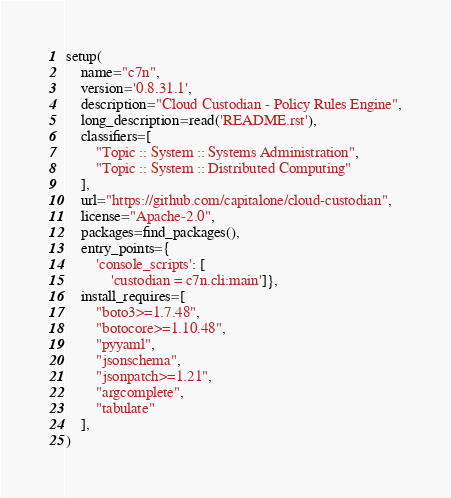Convert code to text. <code><loc_0><loc_0><loc_500><loc_500><_Python_>setup(
    name="c7n",
    version='0.8.31.1',
    description="Cloud Custodian - Policy Rules Engine",
    long_description=read('README.rst'),
    classifiers=[
        "Topic :: System :: Systems Administration",
        "Topic :: System :: Distributed Computing"
    ],
    url="https://github.com/capitalone/cloud-custodian",
    license="Apache-2.0",
    packages=find_packages(),
    entry_points={
        'console_scripts': [
            'custodian = c7n.cli:main']},
    install_requires=[
        "boto3>=1.7.48",
        "botocore>=1.10.48",
        "pyyaml",
        "jsonschema",
        "jsonpatch>=1.21",
        "argcomplete",
        "tabulate"
    ],
)
</code> 